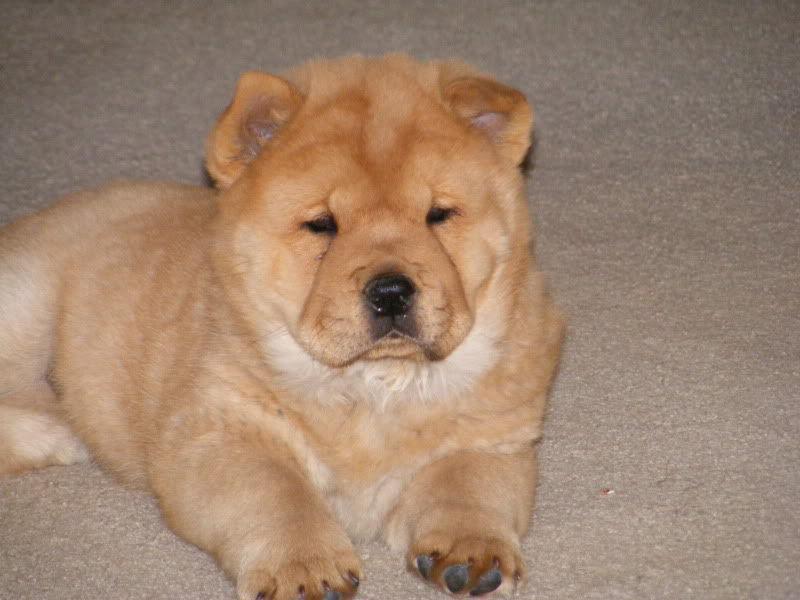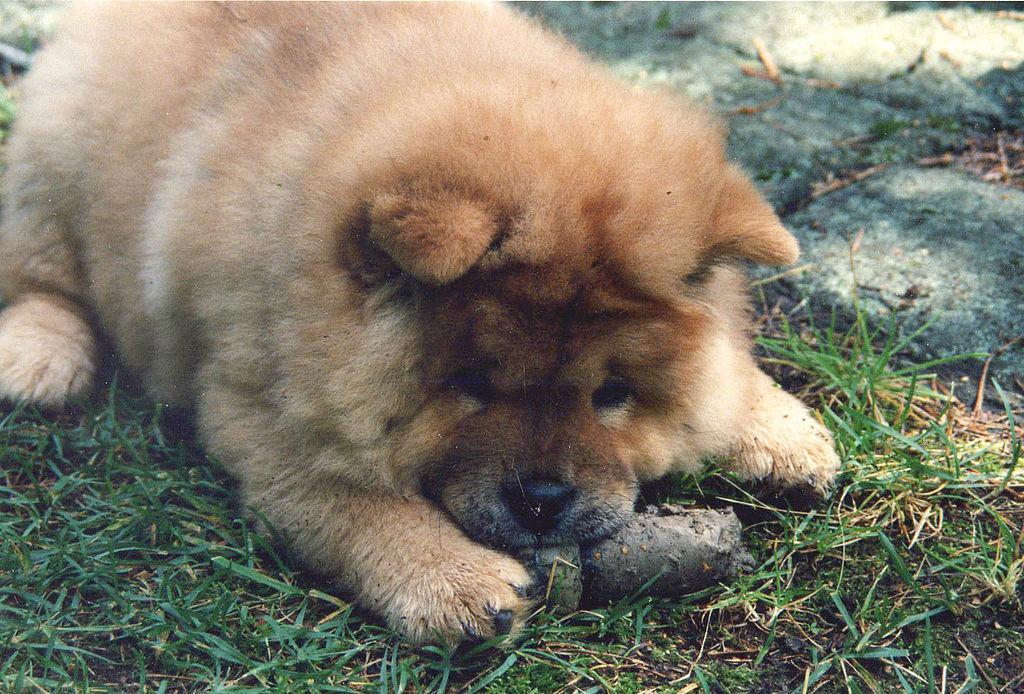The first image is the image on the left, the second image is the image on the right. Given the left and right images, does the statement "Both of the images feature a dog standing on grass." hold true? Answer yes or no. No. The first image is the image on the left, the second image is the image on the right. For the images displayed, is the sentence "Both images feature young chow puppies, and the puppies on the left and right share similar poses with bodies turned in the same direction, but the puppy on the left is not on grass." factually correct? Answer yes or no. Yes. 